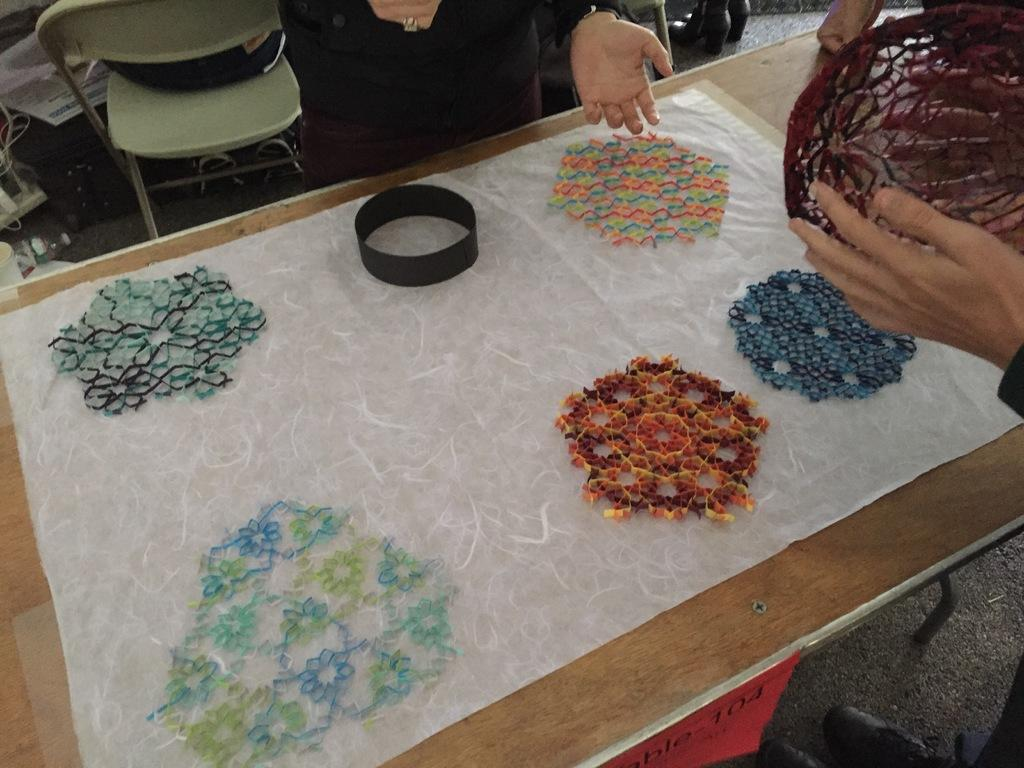What can be observed on the cloth in the image? There are designs on the cloth. Where is the cloth located in the image? The cloth is on a table. Can you describe the people visible in the image? There are people visible in the image, but their specific actions or characteristics are not mentioned in the provided facts. What other objects can be seen in the image besides the cloth and people? There is a chair and a bottle in the image. What type of vegetable is being pushed across the table in the image? There is no vegetable or pushing action visible in the image. 